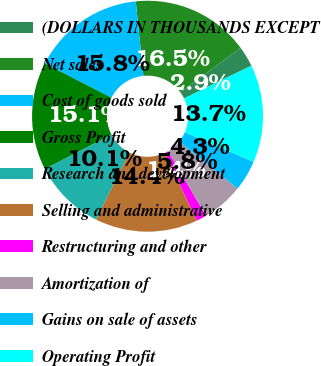Convert chart to OTSL. <chart><loc_0><loc_0><loc_500><loc_500><pie_chart><fcel>(DOLLARS IN THOUSANDS EXCEPT<fcel>Net sales<fcel>Cost of goods sold<fcel>Gross Profit<fcel>Research and development<fcel>Selling and administrative<fcel>Restructuring and other<fcel>Amortization of<fcel>Gains on sale of assets<fcel>Operating Profit<nl><fcel>2.88%<fcel>16.55%<fcel>15.83%<fcel>15.11%<fcel>10.07%<fcel>14.39%<fcel>1.44%<fcel>5.76%<fcel>4.32%<fcel>13.67%<nl></chart> 